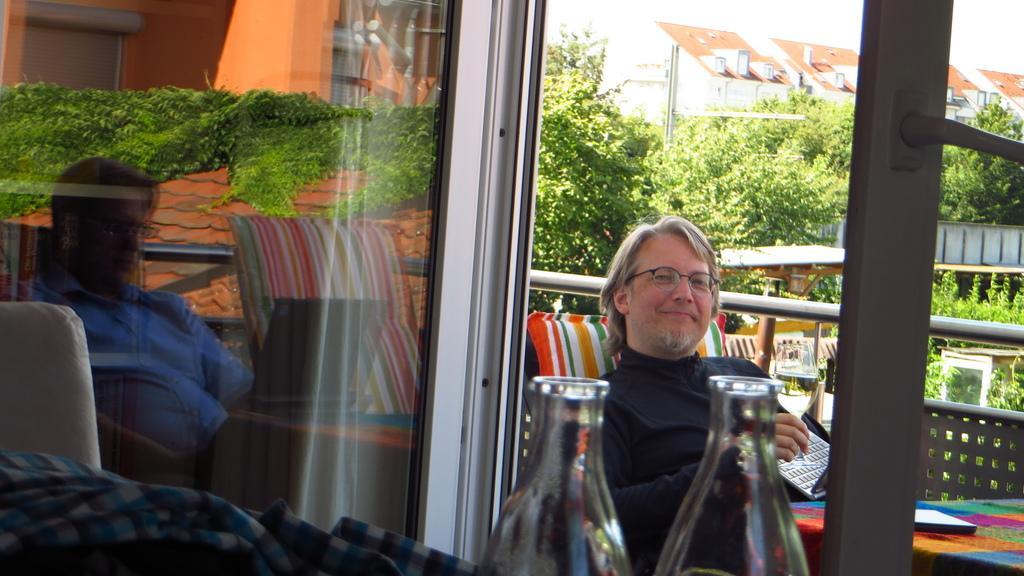How would you summarize this image in a sentence or two? In this image in the front there are bottles and there is a cloth. In the center there is a glass and on the glass there is a reflection of the person and there is a chair. In the background there is a man sitting on the chair and smiling and there is a table in front of the man, on the table there is an object which is black and white in colour and there are trees and houses in the background. On the left side there is an object which is white in colour. 